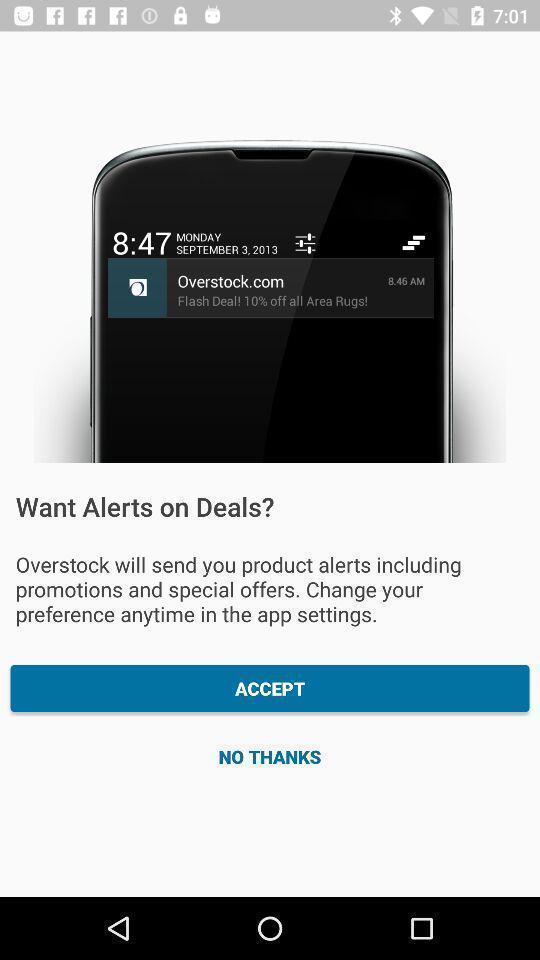What is the overall content of this screenshot? Welcome page displaying to accept or not. 